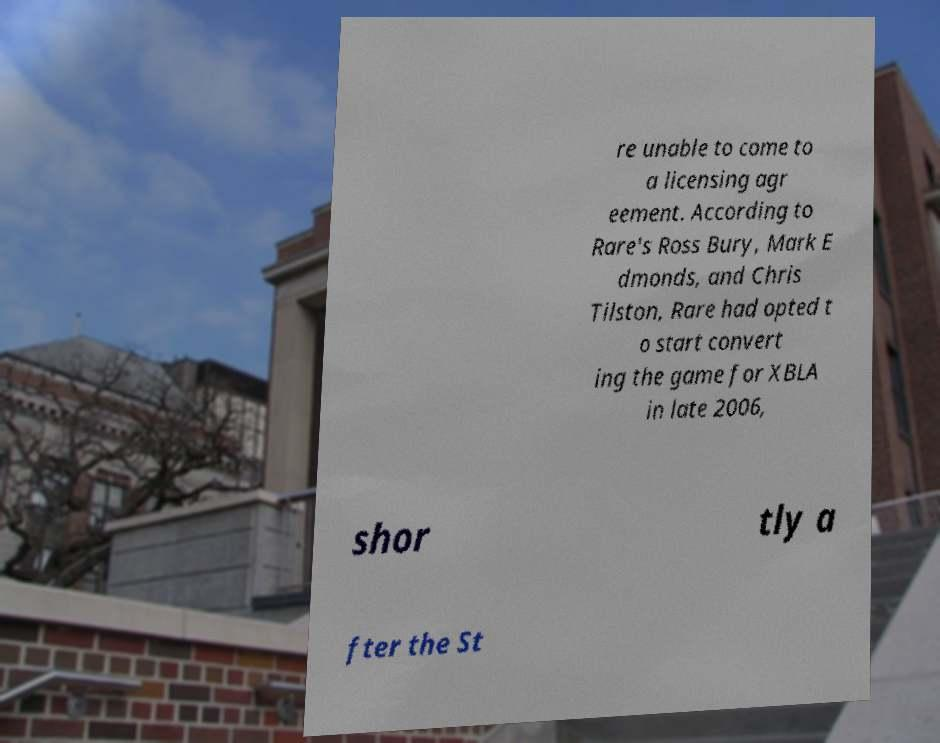There's text embedded in this image that I need extracted. Can you transcribe it verbatim? re unable to come to a licensing agr eement. According to Rare's Ross Bury, Mark E dmonds, and Chris Tilston, Rare had opted t o start convert ing the game for XBLA in late 2006, shor tly a fter the St 